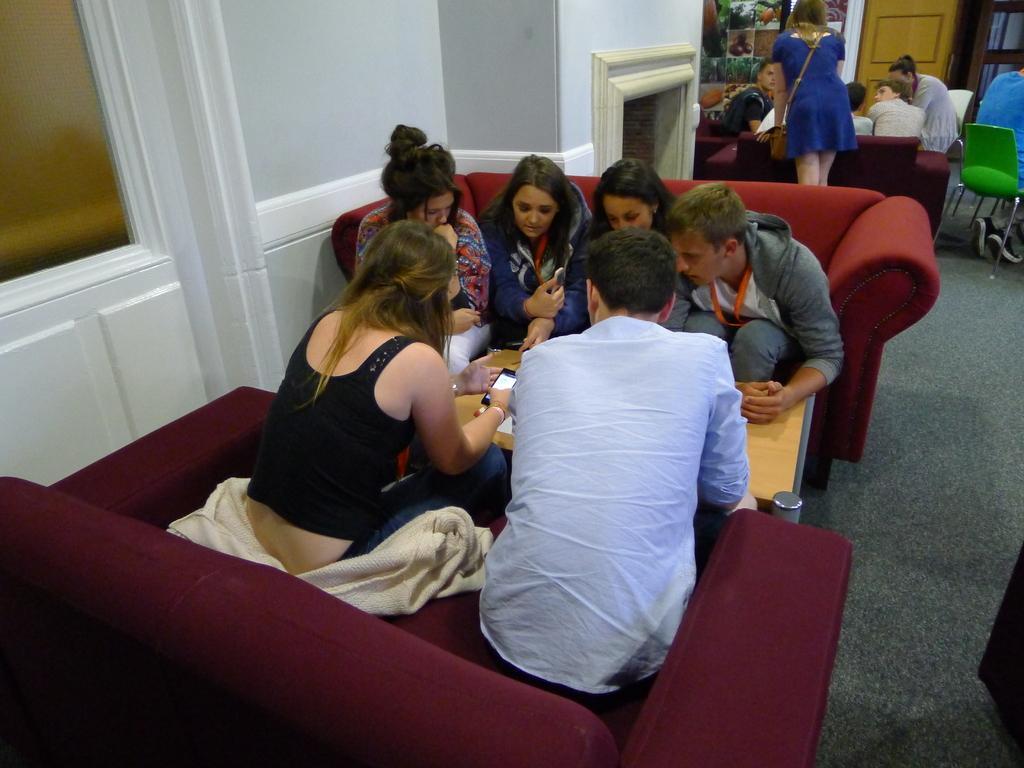Can you describe this image briefly? In the picture there are two sofas and there is a table between,group of people are sitting around the table they are discussing something,in the background also there is another group sitting on the sofa,to the left there is white wall,in the background there is a door and a cupboard. 